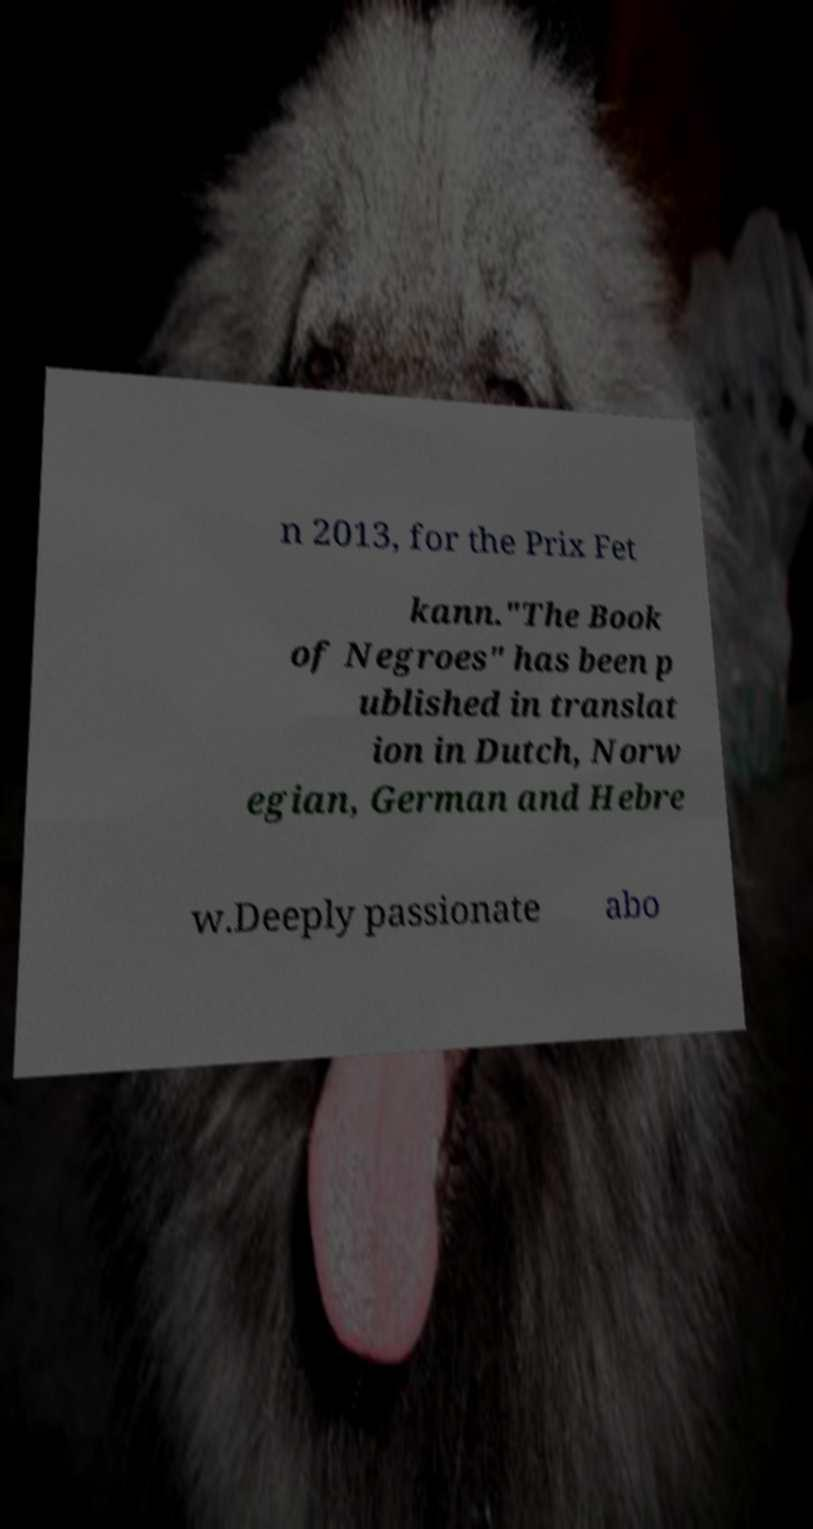Can you read and provide the text displayed in the image?This photo seems to have some interesting text. Can you extract and type it out for me? n 2013, for the Prix Fet kann."The Book of Negroes" has been p ublished in translat ion in Dutch, Norw egian, German and Hebre w.Deeply passionate abo 